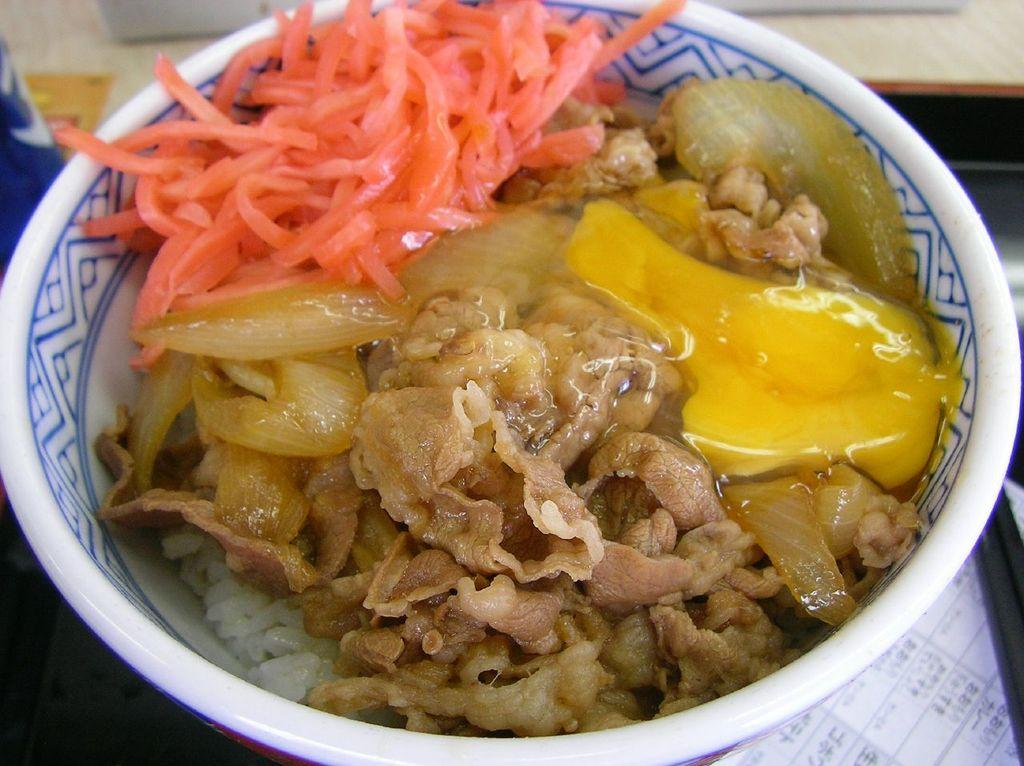What is located in the foreground of the picture? There is a bowl in the foreground of the picture. What is inside the bowl? There is food in the bowl. Can you describe the background of the image? The background of the image is blurred. Are there any pets visible in the hall in the image? There is no hall or pets present in the image; it only features a bowl with food in the foreground and a blurred background. 